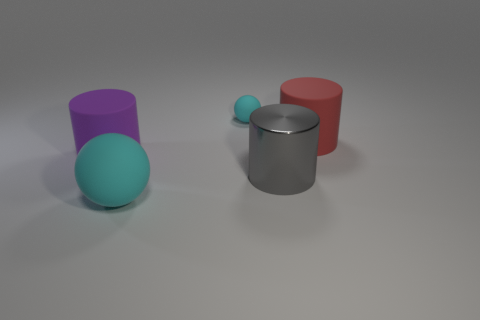Add 3 big cyan matte blocks. How many objects exist? 8 Subtract all cylinders. How many objects are left? 2 Subtract all large red matte objects. Subtract all purple cylinders. How many objects are left? 3 Add 3 gray things. How many gray things are left? 4 Add 2 green metal blocks. How many green metal blocks exist? 2 Subtract 0 blue cylinders. How many objects are left? 5 